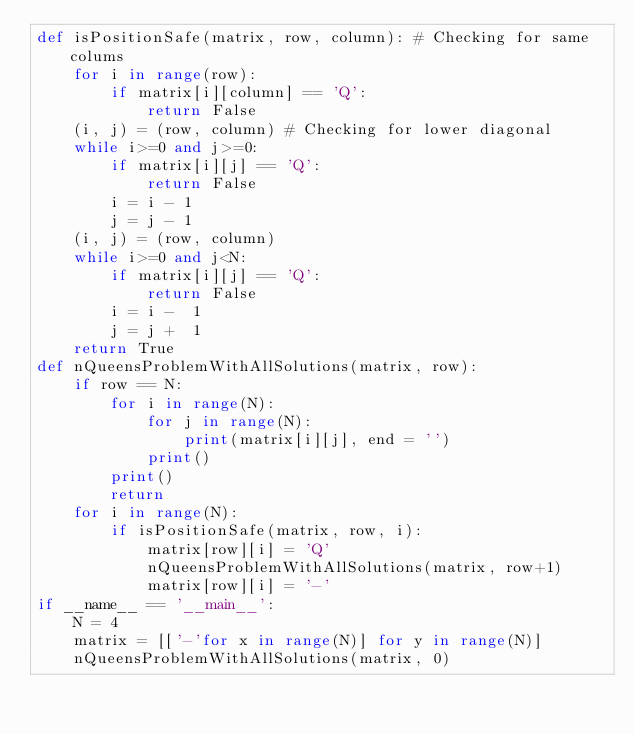Convert code to text. <code><loc_0><loc_0><loc_500><loc_500><_Python_>def isPositionSafe(matrix, row, column): # Checking for same colums
    for i in range(row):
        if matrix[i][column] == 'Q':
            return False
    (i, j) = (row, column) # Checking for lower diagonal
    while i>=0 and j>=0:
        if matrix[i][j] == 'Q':
            return False
        i = i - 1
        j = j - 1
    (i, j) = (row, column)
    while i>=0 and j<N:
        if matrix[i][j] == 'Q':
            return False
        i = i -  1
        j = j +  1  
    return True
def nQueensProblemWithAllSolutions(matrix, row):
    if row == N:
        for i in range(N):
            for j in range(N):
                print(matrix[i][j], end = '')
            print()
        print()
        return
    for i in range(N):
        if isPositionSafe(matrix, row, i):
            matrix[row][i] = 'Q'
            nQueensProblemWithAllSolutions(matrix, row+1)
            matrix[row][i] = '-'
if __name__ == '__main__':
    N = 4
    matrix = [['-'for x in range(N)] for y in range(N)]
    nQueensProblemWithAllSolutions(matrix, 0)

        
</code> 